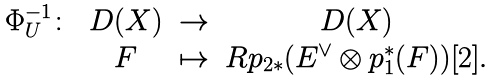Convert formula to latex. <formula><loc_0><loc_0><loc_500><loc_500>\begin{matrix} \Phi _ { U } ^ { - 1 } \colon & { D } ( X ) & \to & { D } ( X ) \\ & F & \mapsto & { R } p _ { 2 * } ( { E } ^ { \vee } \otimes p _ { 1 } ^ { * } ( F ) ) [ 2 ] . \end{matrix}</formula> 